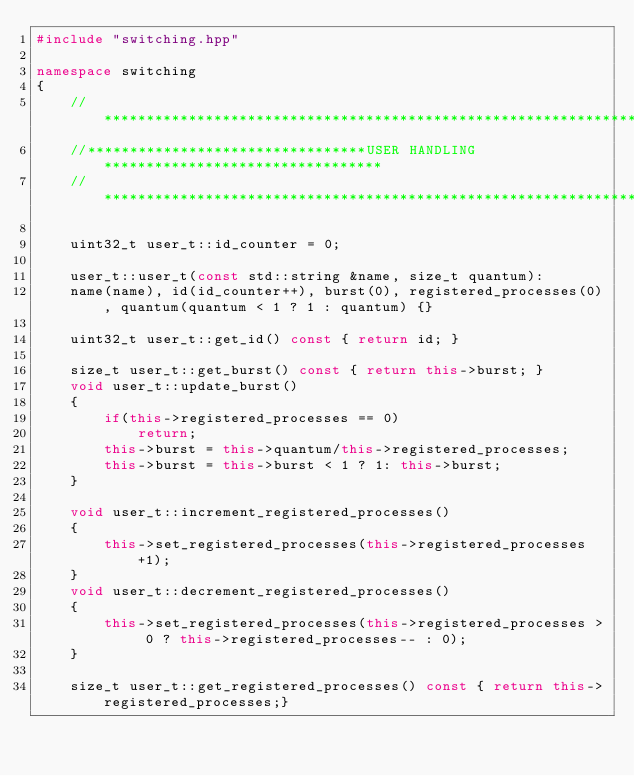Convert code to text. <code><loc_0><loc_0><loc_500><loc_500><_C++_>#include "switching.hpp"

namespace switching
{
    //*******************************************************************************
    //*********************************USER HANDLING*********************************
    //*******************************************************************************
    
    uint32_t user_t::id_counter = 0;
    
    user_t::user_t(const std::string &name, size_t quantum): 
    name(name), id(id_counter++), burst(0), registered_processes(0), quantum(quantum < 1 ? 1 : quantum) {}

    uint32_t user_t::get_id() const { return id; }

    size_t user_t::get_burst() const { return this->burst; }
    void user_t::update_burst() 
    {
        if(this->registered_processes == 0)
            return;
        this->burst = this->quantum/this->registered_processes;
        this->burst = this->burst < 1 ? 1: this->burst;
    }

    void user_t::increment_registered_processes() 
    {
        this->set_registered_processes(this->registered_processes+1);
    }
    void user_t::decrement_registered_processes() 
    {
        this->set_registered_processes(this->registered_processes > 0 ? this->registered_processes-- : 0);
    }

    size_t user_t::get_registered_processes() const { return this->registered_processes;}</code> 